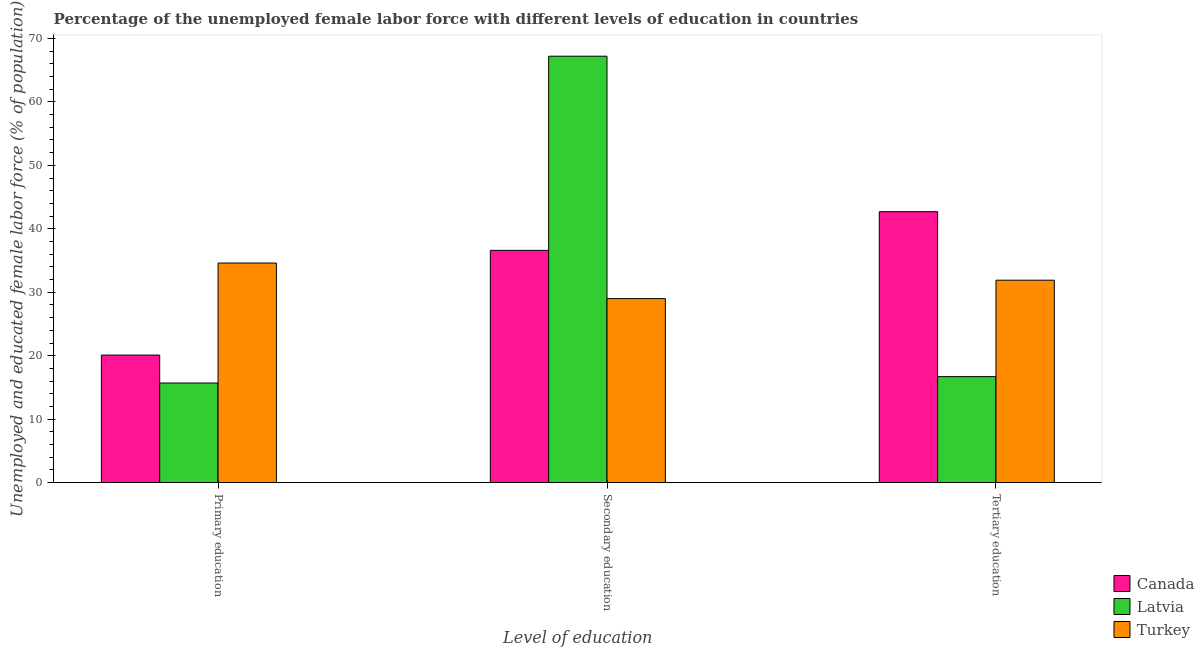How many different coloured bars are there?
Ensure brevity in your answer.  3. Are the number of bars per tick equal to the number of legend labels?
Offer a very short reply. Yes. Are the number of bars on each tick of the X-axis equal?
Offer a terse response. Yes. What is the label of the 2nd group of bars from the left?
Give a very brief answer. Secondary education. What is the percentage of female labor force who received tertiary education in Canada?
Keep it short and to the point. 42.7. Across all countries, what is the maximum percentage of female labor force who received primary education?
Offer a very short reply. 34.6. Across all countries, what is the minimum percentage of female labor force who received secondary education?
Ensure brevity in your answer.  29. In which country was the percentage of female labor force who received tertiary education maximum?
Your response must be concise. Canada. What is the total percentage of female labor force who received tertiary education in the graph?
Keep it short and to the point. 91.3. What is the difference between the percentage of female labor force who received tertiary education in Turkey and that in Canada?
Provide a short and direct response. -10.8. What is the difference between the percentage of female labor force who received tertiary education in Canada and the percentage of female labor force who received primary education in Turkey?
Offer a terse response. 8.1. What is the average percentage of female labor force who received primary education per country?
Ensure brevity in your answer.  23.47. What is the difference between the percentage of female labor force who received tertiary education and percentage of female labor force who received primary education in Canada?
Ensure brevity in your answer.  22.6. In how many countries, is the percentage of female labor force who received primary education greater than 10 %?
Your answer should be compact. 3. What is the ratio of the percentage of female labor force who received primary education in Turkey to that in Canada?
Your answer should be very brief. 1.72. Is the percentage of female labor force who received secondary education in Canada less than that in Turkey?
Give a very brief answer. No. Is the difference between the percentage of female labor force who received primary education in Latvia and Canada greater than the difference between the percentage of female labor force who received secondary education in Latvia and Canada?
Ensure brevity in your answer.  No. What is the difference between the highest and the second highest percentage of female labor force who received secondary education?
Offer a very short reply. 30.6. What is the difference between the highest and the lowest percentage of female labor force who received primary education?
Keep it short and to the point. 18.9. In how many countries, is the percentage of female labor force who received tertiary education greater than the average percentage of female labor force who received tertiary education taken over all countries?
Provide a short and direct response. 2. Is it the case that in every country, the sum of the percentage of female labor force who received primary education and percentage of female labor force who received secondary education is greater than the percentage of female labor force who received tertiary education?
Ensure brevity in your answer.  Yes. How many bars are there?
Offer a very short reply. 9. Are all the bars in the graph horizontal?
Ensure brevity in your answer.  No. How are the legend labels stacked?
Keep it short and to the point. Vertical. What is the title of the graph?
Provide a succinct answer. Percentage of the unemployed female labor force with different levels of education in countries. What is the label or title of the X-axis?
Give a very brief answer. Level of education. What is the label or title of the Y-axis?
Your answer should be very brief. Unemployed and educated female labor force (% of population). What is the Unemployed and educated female labor force (% of population) of Canada in Primary education?
Give a very brief answer. 20.1. What is the Unemployed and educated female labor force (% of population) in Latvia in Primary education?
Your answer should be compact. 15.7. What is the Unemployed and educated female labor force (% of population) in Turkey in Primary education?
Offer a very short reply. 34.6. What is the Unemployed and educated female labor force (% of population) of Canada in Secondary education?
Offer a terse response. 36.6. What is the Unemployed and educated female labor force (% of population) of Latvia in Secondary education?
Your response must be concise. 67.2. What is the Unemployed and educated female labor force (% of population) of Turkey in Secondary education?
Give a very brief answer. 29. What is the Unemployed and educated female labor force (% of population) in Canada in Tertiary education?
Your answer should be compact. 42.7. What is the Unemployed and educated female labor force (% of population) of Latvia in Tertiary education?
Give a very brief answer. 16.7. What is the Unemployed and educated female labor force (% of population) of Turkey in Tertiary education?
Your answer should be very brief. 31.9. Across all Level of education, what is the maximum Unemployed and educated female labor force (% of population) of Canada?
Give a very brief answer. 42.7. Across all Level of education, what is the maximum Unemployed and educated female labor force (% of population) in Latvia?
Offer a terse response. 67.2. Across all Level of education, what is the maximum Unemployed and educated female labor force (% of population) in Turkey?
Offer a very short reply. 34.6. Across all Level of education, what is the minimum Unemployed and educated female labor force (% of population) in Canada?
Your answer should be very brief. 20.1. Across all Level of education, what is the minimum Unemployed and educated female labor force (% of population) in Latvia?
Provide a succinct answer. 15.7. What is the total Unemployed and educated female labor force (% of population) of Canada in the graph?
Your answer should be very brief. 99.4. What is the total Unemployed and educated female labor force (% of population) of Latvia in the graph?
Your response must be concise. 99.6. What is the total Unemployed and educated female labor force (% of population) of Turkey in the graph?
Keep it short and to the point. 95.5. What is the difference between the Unemployed and educated female labor force (% of population) of Canada in Primary education and that in Secondary education?
Give a very brief answer. -16.5. What is the difference between the Unemployed and educated female labor force (% of population) of Latvia in Primary education and that in Secondary education?
Your response must be concise. -51.5. What is the difference between the Unemployed and educated female labor force (% of population) of Canada in Primary education and that in Tertiary education?
Your response must be concise. -22.6. What is the difference between the Unemployed and educated female labor force (% of population) of Latvia in Primary education and that in Tertiary education?
Offer a very short reply. -1. What is the difference between the Unemployed and educated female labor force (% of population) of Turkey in Primary education and that in Tertiary education?
Offer a very short reply. 2.7. What is the difference between the Unemployed and educated female labor force (% of population) in Canada in Secondary education and that in Tertiary education?
Offer a terse response. -6.1. What is the difference between the Unemployed and educated female labor force (% of population) in Latvia in Secondary education and that in Tertiary education?
Offer a terse response. 50.5. What is the difference between the Unemployed and educated female labor force (% of population) of Turkey in Secondary education and that in Tertiary education?
Keep it short and to the point. -2.9. What is the difference between the Unemployed and educated female labor force (% of population) in Canada in Primary education and the Unemployed and educated female labor force (% of population) in Latvia in Secondary education?
Your answer should be very brief. -47.1. What is the difference between the Unemployed and educated female labor force (% of population) in Canada in Primary education and the Unemployed and educated female labor force (% of population) in Turkey in Tertiary education?
Ensure brevity in your answer.  -11.8. What is the difference between the Unemployed and educated female labor force (% of population) of Latvia in Primary education and the Unemployed and educated female labor force (% of population) of Turkey in Tertiary education?
Give a very brief answer. -16.2. What is the difference between the Unemployed and educated female labor force (% of population) in Latvia in Secondary education and the Unemployed and educated female labor force (% of population) in Turkey in Tertiary education?
Give a very brief answer. 35.3. What is the average Unemployed and educated female labor force (% of population) in Canada per Level of education?
Keep it short and to the point. 33.13. What is the average Unemployed and educated female labor force (% of population) in Latvia per Level of education?
Provide a succinct answer. 33.2. What is the average Unemployed and educated female labor force (% of population) of Turkey per Level of education?
Offer a very short reply. 31.83. What is the difference between the Unemployed and educated female labor force (% of population) in Latvia and Unemployed and educated female labor force (% of population) in Turkey in Primary education?
Ensure brevity in your answer.  -18.9. What is the difference between the Unemployed and educated female labor force (% of population) of Canada and Unemployed and educated female labor force (% of population) of Latvia in Secondary education?
Offer a terse response. -30.6. What is the difference between the Unemployed and educated female labor force (% of population) in Latvia and Unemployed and educated female labor force (% of population) in Turkey in Secondary education?
Offer a terse response. 38.2. What is the difference between the Unemployed and educated female labor force (% of population) in Canada and Unemployed and educated female labor force (% of population) in Turkey in Tertiary education?
Keep it short and to the point. 10.8. What is the difference between the Unemployed and educated female labor force (% of population) in Latvia and Unemployed and educated female labor force (% of population) in Turkey in Tertiary education?
Your answer should be compact. -15.2. What is the ratio of the Unemployed and educated female labor force (% of population) in Canada in Primary education to that in Secondary education?
Your answer should be very brief. 0.55. What is the ratio of the Unemployed and educated female labor force (% of population) in Latvia in Primary education to that in Secondary education?
Offer a terse response. 0.23. What is the ratio of the Unemployed and educated female labor force (% of population) of Turkey in Primary education to that in Secondary education?
Ensure brevity in your answer.  1.19. What is the ratio of the Unemployed and educated female labor force (% of population) in Canada in Primary education to that in Tertiary education?
Your answer should be very brief. 0.47. What is the ratio of the Unemployed and educated female labor force (% of population) of Latvia in Primary education to that in Tertiary education?
Make the answer very short. 0.94. What is the ratio of the Unemployed and educated female labor force (% of population) of Turkey in Primary education to that in Tertiary education?
Your response must be concise. 1.08. What is the ratio of the Unemployed and educated female labor force (% of population) of Canada in Secondary education to that in Tertiary education?
Your response must be concise. 0.86. What is the ratio of the Unemployed and educated female labor force (% of population) of Latvia in Secondary education to that in Tertiary education?
Your response must be concise. 4.02. What is the difference between the highest and the second highest Unemployed and educated female labor force (% of population) in Latvia?
Provide a succinct answer. 50.5. What is the difference between the highest and the second highest Unemployed and educated female labor force (% of population) in Turkey?
Make the answer very short. 2.7. What is the difference between the highest and the lowest Unemployed and educated female labor force (% of population) of Canada?
Your answer should be very brief. 22.6. What is the difference between the highest and the lowest Unemployed and educated female labor force (% of population) of Latvia?
Provide a short and direct response. 51.5. What is the difference between the highest and the lowest Unemployed and educated female labor force (% of population) of Turkey?
Offer a very short reply. 5.6. 